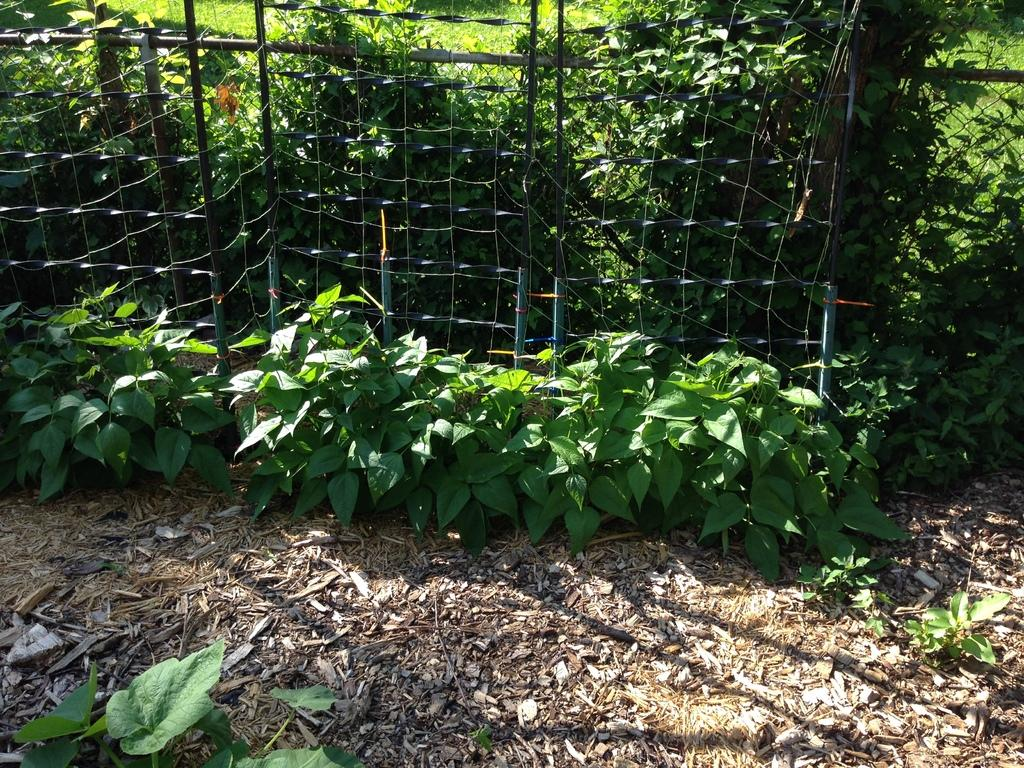What is located in the middle of the image? There are plants and a net in the middle of the image. Can you describe the plants in the image? The provided facts do not give specific details about the plants, so we cannot describe them further. What is the purpose of the net in the image? The purpose of the net in the image is not specified in the provided facts. How many yaks are visible in the image? There are no yaks present in the image. What type of stone is used to create the net in the image? The provided facts do not mention any stones being used to create the net in the image. 